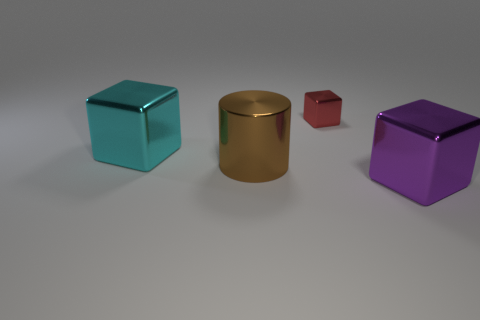Do the materials of the objects differ in any noticeable way? Yes, they do. The gold object has a reflective metallic finish, while the other three objects, in teal, red, and purple, exhibit a matte surface which doesn't reflect much light. 